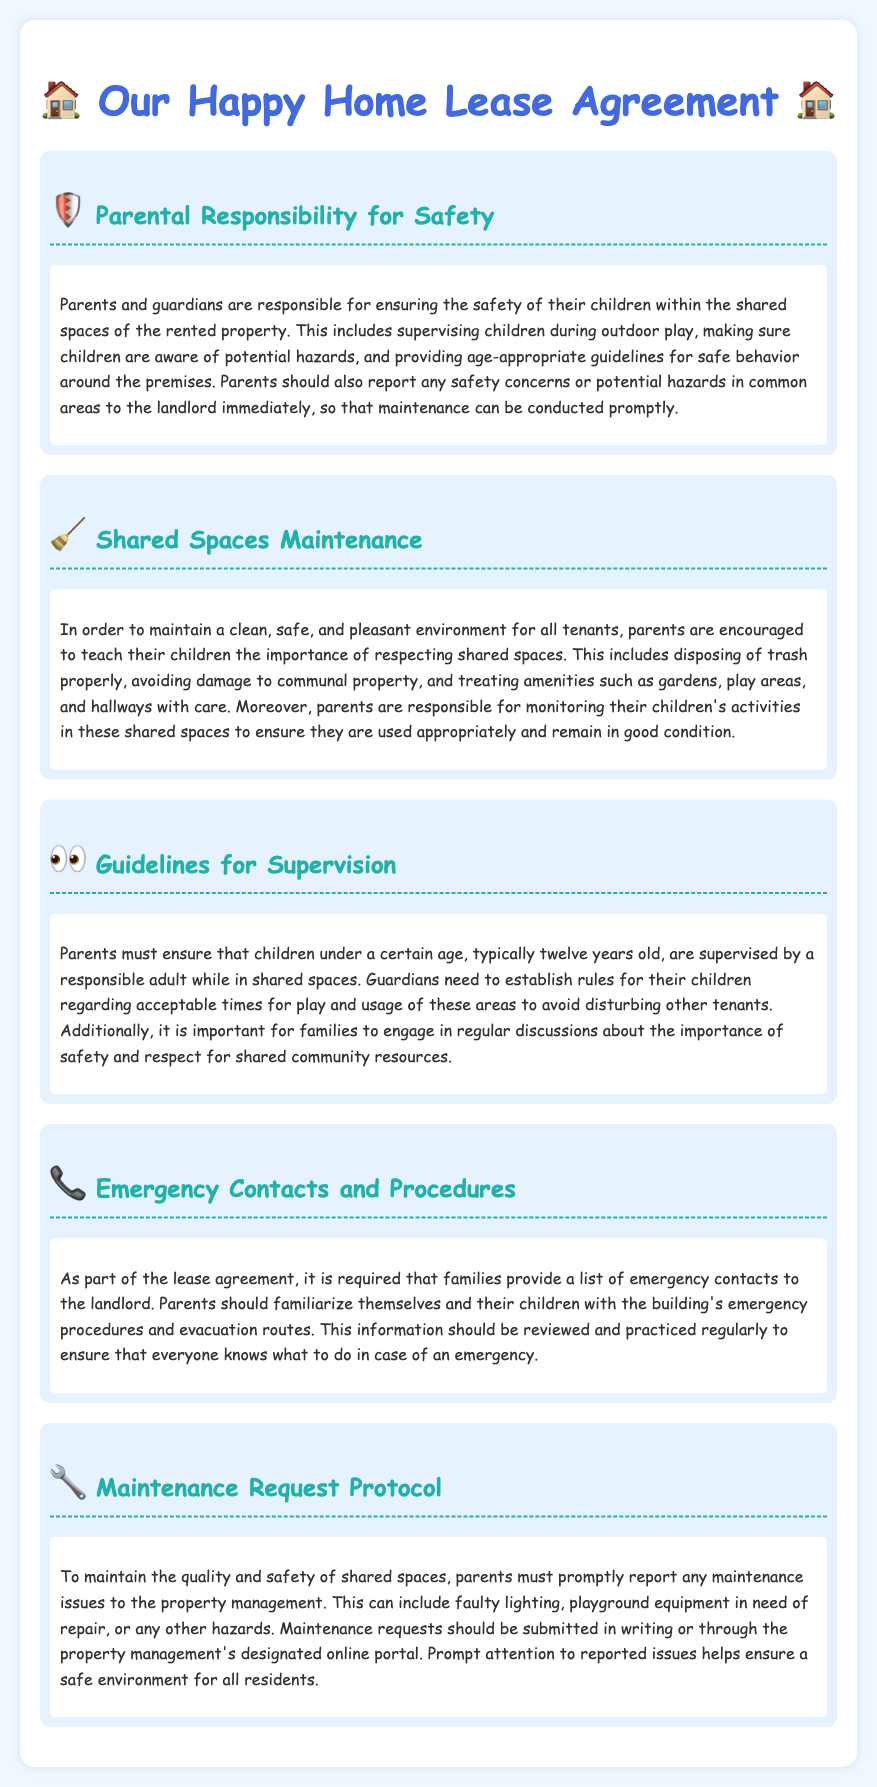What are parents responsible for in shared spaces? Parents and guardians are responsible for ensuring the safety of their children within the shared spaces of the rented property.
Answer: Safety What should parents teach their children about shared spaces? Parents are encouraged to teach their children the importance of respecting shared spaces.
Answer: Respect What age should children be supervised in shared spaces? Parents must ensure that children under a certain age, typically twelve years old, are supervised by a responsible adult.
Answer: Twelve What must families provide to the landlord for emergencies? It is required that families provide a list of emergency contacts to the landlord.
Answer: Emergency contacts What should parents do if they see a maintenance issue? Parents must promptly report any maintenance issues to the property management.
Answer: Report Why is supervision of children in shared spaces important? It is important for families to engage in regular discussions about the importance of safety and respect for shared community resources.
Answer: Safety and respect What is the suggested method to submit maintenance requests? Maintenance requests should be submitted in writing or through the property management's designated online portal.
Answer: Writing or online portal What type of play should parents guide their children to avoid? Guardians need to establish rules for their children regarding acceptable times for play and usage of these areas to avoid disturbing other tenants.
Answer: Disturbance What should parents familiarize their children with regarding emergencies? Parents should familiarize themselves and their children with the building's emergency procedures and evacuation routes.
Answer: Emergency procedures 